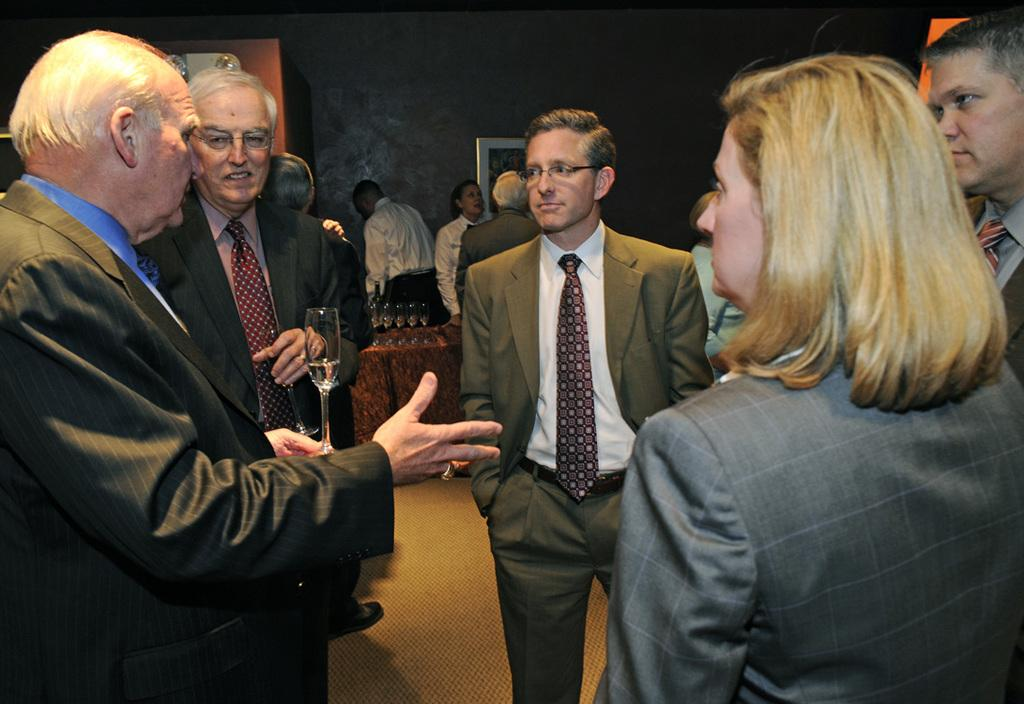How many people are in the image? There are people in the image, but the exact number is not specified. What are two people doing in the image? Two people are holding glasses in the image. What else can be seen on the table besides the glasses? There are glasses on the table, but the facts do not mention any other items. What is hanging on the wall in the image? There is a photo frame on the wall in the image. What type of furniture is present in the image? There is a closet in the image. What type of heart-shaped umbrella is being used for teaching in the image? There is no heart-shaped umbrella or any teaching activity present in the image. 